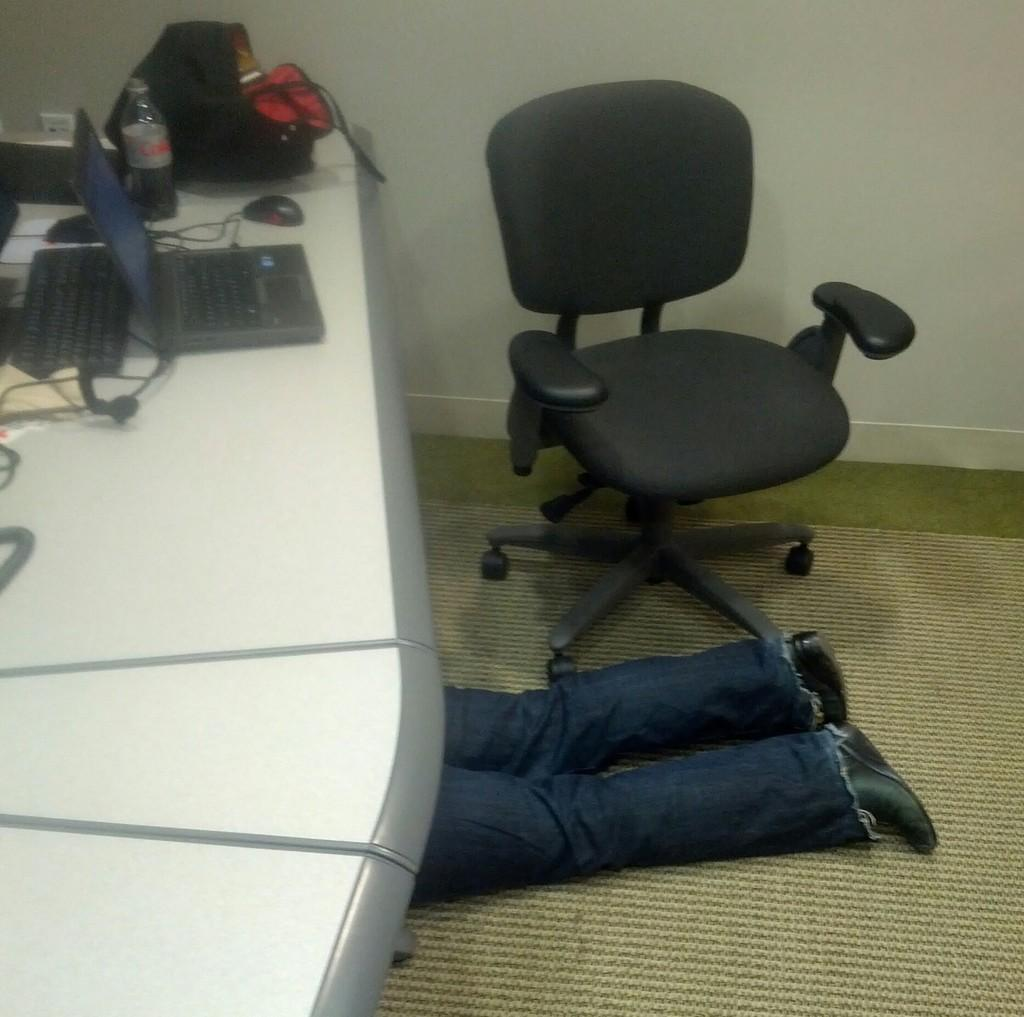Who or what is under the table in the image? There is a person under the table in the image. What is on the table in the image? There is a laptop, a bottle, and other unspecified things on the table in the image. What is the position of the chair in relation to the table? There is a chair to the side of the table in the image. What type of lamp is being used as a prop in the joke being told by the person under the table? There is no lamp present in the image, nor is there any indication of a joke being told. 